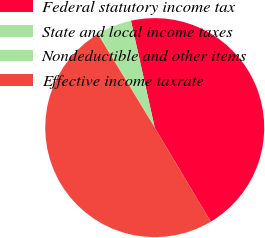Convert chart. <chart><loc_0><loc_0><loc_500><loc_500><pie_chart><fcel>Federal statutory income tax<fcel>State and local income taxes<fcel>Nondeductible and other items<fcel>Effective income taxrate<nl><fcel>44.92%<fcel>5.08%<fcel>0.13%<fcel>49.87%<nl></chart> 